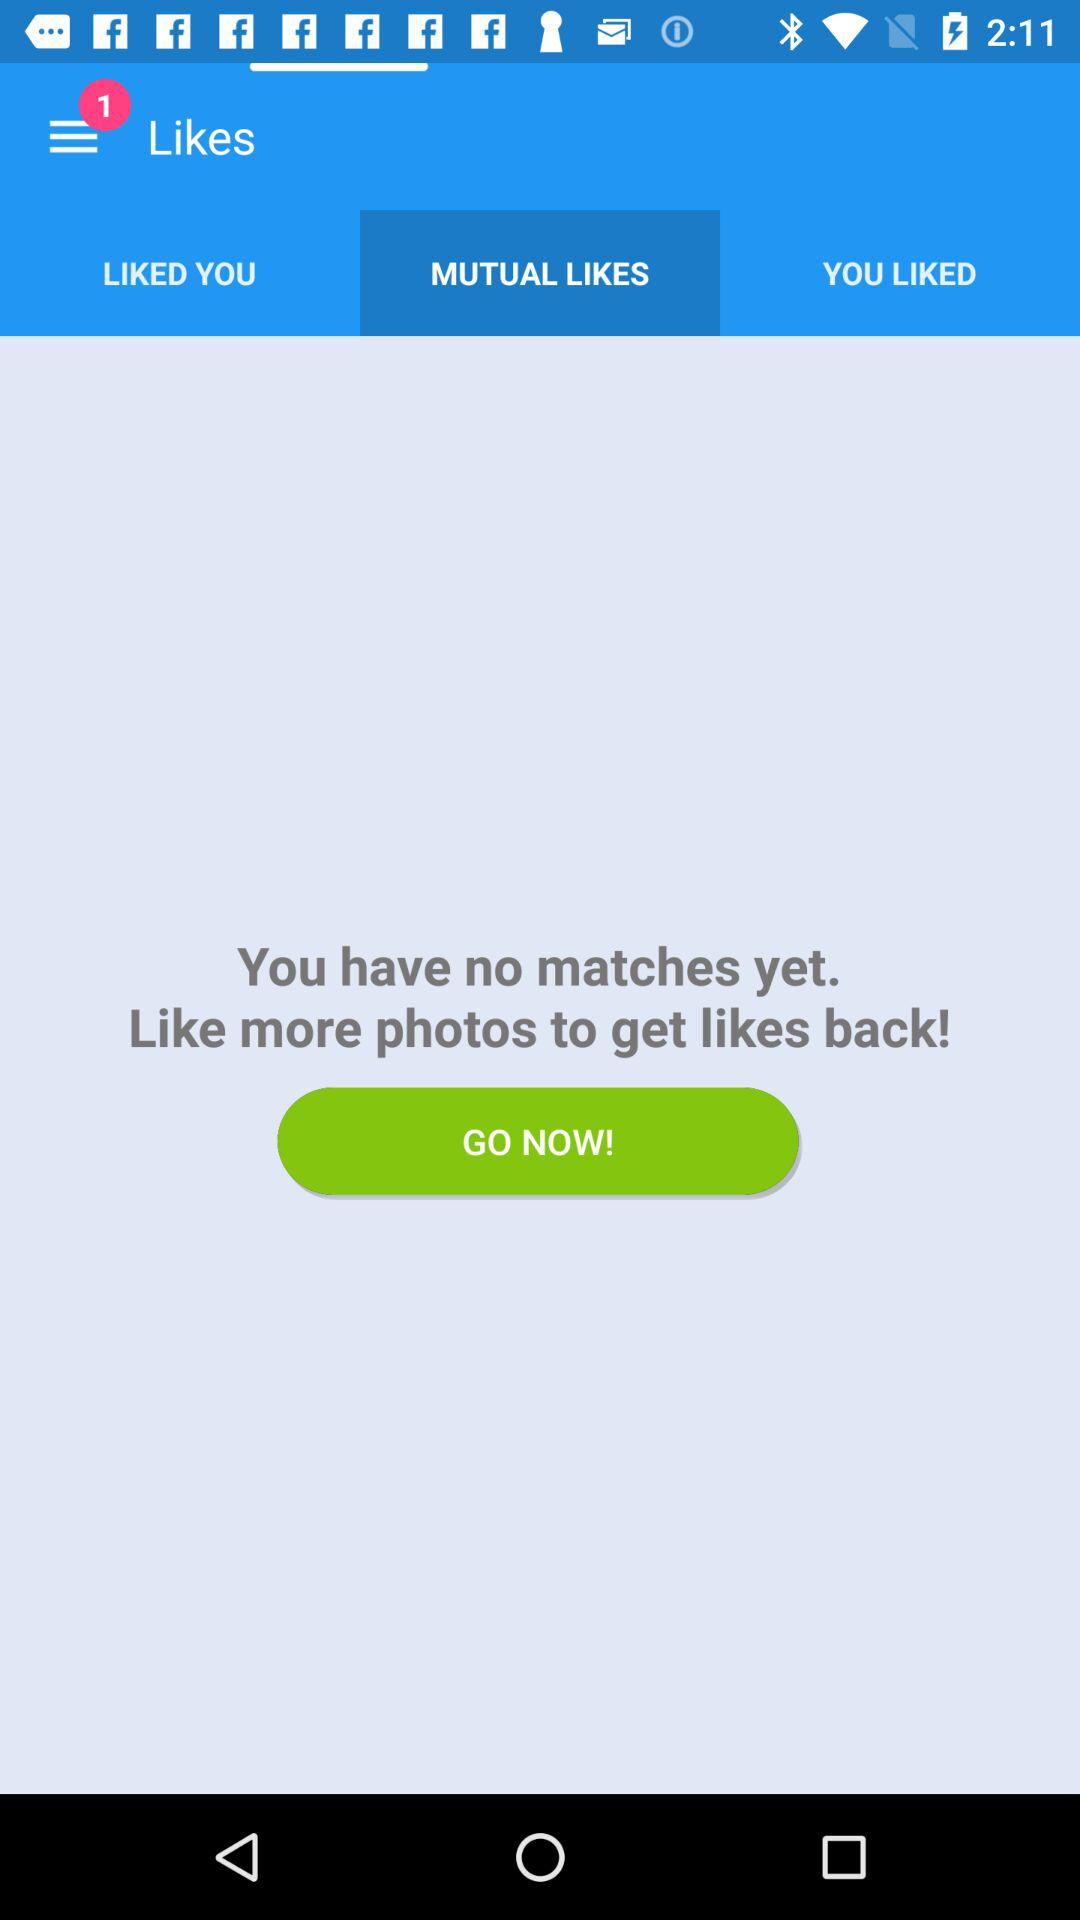What is the number of notifications? The number of notifications is 1. 